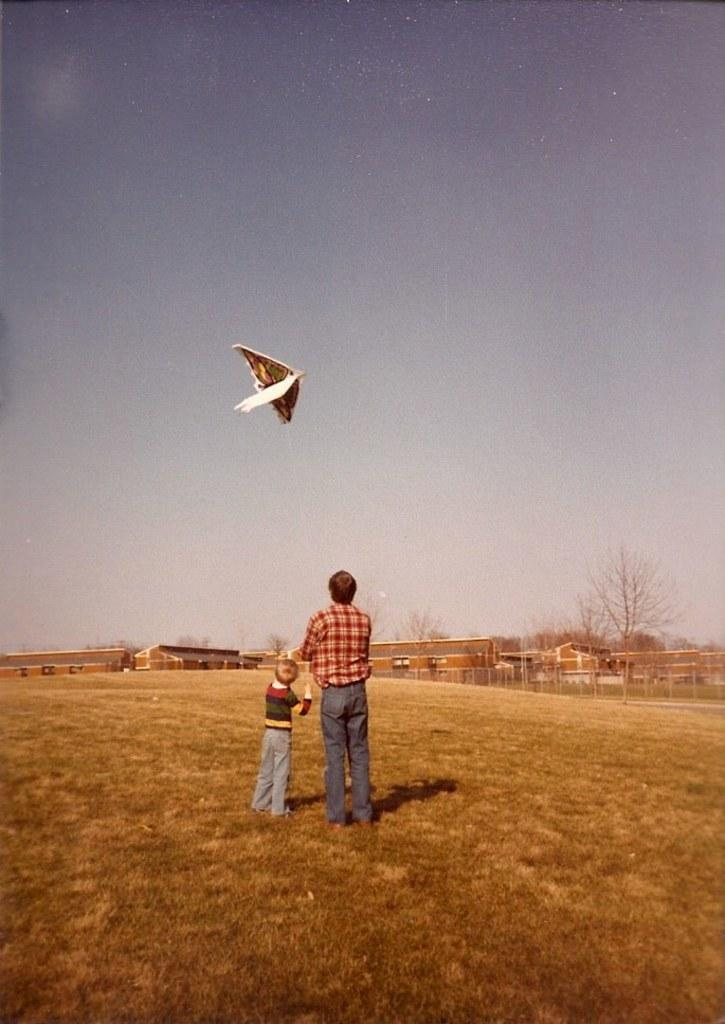How many people are standing on the grass in the image? There are two persons standing on the grass in the image. What is the object in the air? The provided facts do not specify the object in the air, so we cannot definitively answer this question. What can be seen in the background of the image? There are buildings, trees, and clouds in the sky in the background of the image. What color is the vein visible on the dad's forehead in the image? There is no dad or vein visible on anyone's forehead in the image. 